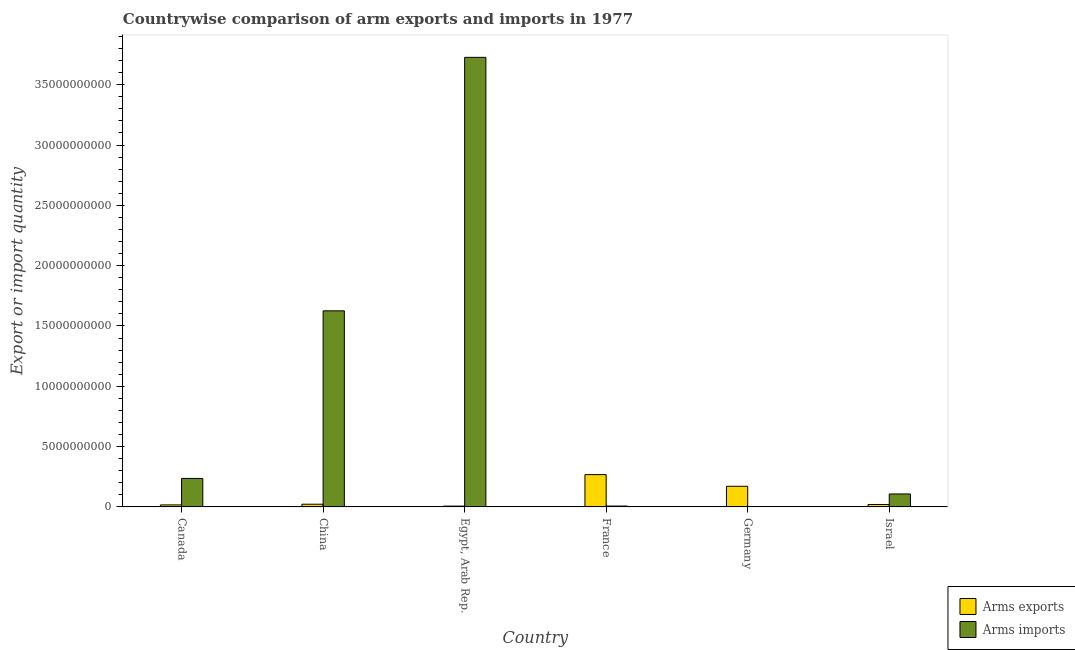How many groups of bars are there?
Make the answer very short. 6. Are the number of bars on each tick of the X-axis equal?
Your response must be concise. Yes. How many bars are there on the 6th tick from the left?
Your answer should be compact. 2. What is the label of the 4th group of bars from the left?
Give a very brief answer. France. What is the arms imports in Egypt, Arab Rep.?
Offer a very short reply. 3.73e+1. Across all countries, what is the maximum arms exports?
Offer a terse response. 2.68e+09. Across all countries, what is the minimum arms exports?
Your answer should be very brief. 6.90e+07. In which country was the arms imports maximum?
Provide a short and direct response. Egypt, Arab Rep. In which country was the arms exports minimum?
Ensure brevity in your answer.  Egypt, Arab Rep. What is the total arms exports in the graph?
Keep it short and to the point. 5.05e+09. What is the difference between the arms exports in Canada and that in China?
Keep it short and to the point. -5.70e+07. What is the difference between the arms exports in China and the arms imports in France?
Keep it short and to the point. 1.50e+08. What is the average arms imports per country?
Your answer should be compact. 9.51e+09. What is the difference between the arms imports and arms exports in Israel?
Keep it short and to the point. 8.73e+08. What is the ratio of the arms exports in China to that in Egypt, Arab Rep.?
Your answer should be compact. 3.25. What is the difference between the highest and the second highest arms exports?
Your response must be concise. 9.66e+08. What is the difference between the highest and the lowest arms imports?
Your response must be concise. 3.73e+1. Is the sum of the arms exports in China and Germany greater than the maximum arms imports across all countries?
Provide a succinct answer. No. What does the 2nd bar from the left in Canada represents?
Your answer should be very brief. Arms imports. What does the 1st bar from the right in France represents?
Offer a very short reply. Arms imports. How many bars are there?
Provide a short and direct response. 12. What is the difference between two consecutive major ticks on the Y-axis?
Ensure brevity in your answer.  5.00e+09. How many legend labels are there?
Your response must be concise. 2. What is the title of the graph?
Your response must be concise. Countrywise comparison of arm exports and imports in 1977. Does "Measles" appear as one of the legend labels in the graph?
Ensure brevity in your answer.  No. What is the label or title of the Y-axis?
Provide a short and direct response. Export or import quantity. What is the Export or import quantity in Arms exports in Canada?
Offer a very short reply. 1.67e+08. What is the Export or import quantity of Arms imports in Canada?
Your response must be concise. 2.36e+09. What is the Export or import quantity in Arms exports in China?
Provide a succinct answer. 2.24e+08. What is the Export or import quantity in Arms imports in China?
Offer a very short reply. 1.63e+1. What is the Export or import quantity in Arms exports in Egypt, Arab Rep.?
Your answer should be very brief. 6.90e+07. What is the Export or import quantity of Arms imports in Egypt, Arab Rep.?
Your answer should be compact. 3.73e+1. What is the Export or import quantity of Arms exports in France?
Provide a short and direct response. 2.68e+09. What is the Export or import quantity in Arms imports in France?
Ensure brevity in your answer.  7.40e+07. What is the Export or import quantity of Arms exports in Germany?
Ensure brevity in your answer.  1.71e+09. What is the Export or import quantity of Arms exports in Israel?
Make the answer very short. 2.02e+08. What is the Export or import quantity of Arms imports in Israel?
Offer a very short reply. 1.08e+09. Across all countries, what is the maximum Export or import quantity in Arms exports?
Provide a succinct answer. 2.68e+09. Across all countries, what is the maximum Export or import quantity in Arms imports?
Your response must be concise. 3.73e+1. Across all countries, what is the minimum Export or import quantity of Arms exports?
Make the answer very short. 6.90e+07. Across all countries, what is the minimum Export or import quantity of Arms imports?
Offer a very short reply. 7.00e+06. What is the total Export or import quantity of Arms exports in the graph?
Ensure brevity in your answer.  5.05e+09. What is the total Export or import quantity in Arms imports in the graph?
Keep it short and to the point. 5.70e+1. What is the difference between the Export or import quantity in Arms exports in Canada and that in China?
Keep it short and to the point. -5.70e+07. What is the difference between the Export or import quantity of Arms imports in Canada and that in China?
Offer a terse response. -1.39e+1. What is the difference between the Export or import quantity in Arms exports in Canada and that in Egypt, Arab Rep.?
Ensure brevity in your answer.  9.80e+07. What is the difference between the Export or import quantity of Arms imports in Canada and that in Egypt, Arab Rep.?
Ensure brevity in your answer.  -3.49e+1. What is the difference between the Export or import quantity of Arms exports in Canada and that in France?
Keep it short and to the point. -2.51e+09. What is the difference between the Export or import quantity in Arms imports in Canada and that in France?
Ensure brevity in your answer.  2.29e+09. What is the difference between the Export or import quantity in Arms exports in Canada and that in Germany?
Offer a terse response. -1.54e+09. What is the difference between the Export or import quantity in Arms imports in Canada and that in Germany?
Ensure brevity in your answer.  2.36e+09. What is the difference between the Export or import quantity in Arms exports in Canada and that in Israel?
Your answer should be very brief. -3.50e+07. What is the difference between the Export or import quantity of Arms imports in Canada and that in Israel?
Offer a very short reply. 1.29e+09. What is the difference between the Export or import quantity of Arms exports in China and that in Egypt, Arab Rep.?
Keep it short and to the point. 1.55e+08. What is the difference between the Export or import quantity in Arms imports in China and that in Egypt, Arab Rep.?
Keep it short and to the point. -2.10e+1. What is the difference between the Export or import quantity in Arms exports in China and that in France?
Offer a terse response. -2.45e+09. What is the difference between the Export or import quantity in Arms imports in China and that in France?
Make the answer very short. 1.62e+1. What is the difference between the Export or import quantity in Arms exports in China and that in Germany?
Keep it short and to the point. -1.49e+09. What is the difference between the Export or import quantity in Arms imports in China and that in Germany?
Your answer should be compact. 1.62e+1. What is the difference between the Export or import quantity in Arms exports in China and that in Israel?
Offer a terse response. 2.20e+07. What is the difference between the Export or import quantity of Arms imports in China and that in Israel?
Your response must be concise. 1.52e+1. What is the difference between the Export or import quantity in Arms exports in Egypt, Arab Rep. and that in France?
Your answer should be very brief. -2.61e+09. What is the difference between the Export or import quantity in Arms imports in Egypt, Arab Rep. and that in France?
Your response must be concise. 3.72e+1. What is the difference between the Export or import quantity of Arms exports in Egypt, Arab Rep. and that in Germany?
Make the answer very short. -1.64e+09. What is the difference between the Export or import quantity in Arms imports in Egypt, Arab Rep. and that in Germany?
Your answer should be very brief. 3.73e+1. What is the difference between the Export or import quantity of Arms exports in Egypt, Arab Rep. and that in Israel?
Keep it short and to the point. -1.33e+08. What is the difference between the Export or import quantity of Arms imports in Egypt, Arab Rep. and that in Israel?
Offer a very short reply. 3.62e+1. What is the difference between the Export or import quantity in Arms exports in France and that in Germany?
Offer a terse response. 9.66e+08. What is the difference between the Export or import quantity in Arms imports in France and that in Germany?
Your answer should be very brief. 6.70e+07. What is the difference between the Export or import quantity of Arms exports in France and that in Israel?
Keep it short and to the point. 2.48e+09. What is the difference between the Export or import quantity in Arms imports in France and that in Israel?
Ensure brevity in your answer.  -1.00e+09. What is the difference between the Export or import quantity in Arms exports in Germany and that in Israel?
Make the answer very short. 1.51e+09. What is the difference between the Export or import quantity of Arms imports in Germany and that in Israel?
Your answer should be compact. -1.07e+09. What is the difference between the Export or import quantity of Arms exports in Canada and the Export or import quantity of Arms imports in China?
Keep it short and to the point. -1.61e+1. What is the difference between the Export or import quantity in Arms exports in Canada and the Export or import quantity in Arms imports in Egypt, Arab Rep.?
Offer a terse response. -3.71e+1. What is the difference between the Export or import quantity of Arms exports in Canada and the Export or import quantity of Arms imports in France?
Your response must be concise. 9.30e+07. What is the difference between the Export or import quantity in Arms exports in Canada and the Export or import quantity in Arms imports in Germany?
Offer a terse response. 1.60e+08. What is the difference between the Export or import quantity in Arms exports in Canada and the Export or import quantity in Arms imports in Israel?
Your answer should be compact. -9.08e+08. What is the difference between the Export or import quantity in Arms exports in China and the Export or import quantity in Arms imports in Egypt, Arab Rep.?
Ensure brevity in your answer.  -3.70e+1. What is the difference between the Export or import quantity of Arms exports in China and the Export or import quantity of Arms imports in France?
Offer a very short reply. 1.50e+08. What is the difference between the Export or import quantity of Arms exports in China and the Export or import quantity of Arms imports in Germany?
Keep it short and to the point. 2.17e+08. What is the difference between the Export or import quantity in Arms exports in China and the Export or import quantity in Arms imports in Israel?
Ensure brevity in your answer.  -8.51e+08. What is the difference between the Export or import quantity of Arms exports in Egypt, Arab Rep. and the Export or import quantity of Arms imports in France?
Your response must be concise. -5.00e+06. What is the difference between the Export or import quantity of Arms exports in Egypt, Arab Rep. and the Export or import quantity of Arms imports in Germany?
Make the answer very short. 6.20e+07. What is the difference between the Export or import quantity in Arms exports in Egypt, Arab Rep. and the Export or import quantity in Arms imports in Israel?
Keep it short and to the point. -1.01e+09. What is the difference between the Export or import quantity of Arms exports in France and the Export or import quantity of Arms imports in Germany?
Keep it short and to the point. 2.67e+09. What is the difference between the Export or import quantity of Arms exports in France and the Export or import quantity of Arms imports in Israel?
Give a very brief answer. 1.60e+09. What is the difference between the Export or import quantity in Arms exports in Germany and the Export or import quantity in Arms imports in Israel?
Your answer should be very brief. 6.37e+08. What is the average Export or import quantity in Arms exports per country?
Provide a succinct answer. 8.42e+08. What is the average Export or import quantity of Arms imports per country?
Your answer should be compact. 9.51e+09. What is the difference between the Export or import quantity in Arms exports and Export or import quantity in Arms imports in Canada?
Offer a terse response. -2.20e+09. What is the difference between the Export or import quantity of Arms exports and Export or import quantity of Arms imports in China?
Your response must be concise. -1.60e+1. What is the difference between the Export or import quantity of Arms exports and Export or import quantity of Arms imports in Egypt, Arab Rep.?
Make the answer very short. -3.72e+1. What is the difference between the Export or import quantity of Arms exports and Export or import quantity of Arms imports in France?
Offer a very short reply. 2.60e+09. What is the difference between the Export or import quantity of Arms exports and Export or import quantity of Arms imports in Germany?
Offer a terse response. 1.70e+09. What is the difference between the Export or import quantity in Arms exports and Export or import quantity in Arms imports in Israel?
Make the answer very short. -8.73e+08. What is the ratio of the Export or import quantity in Arms exports in Canada to that in China?
Offer a terse response. 0.75. What is the ratio of the Export or import quantity of Arms imports in Canada to that in China?
Make the answer very short. 0.15. What is the ratio of the Export or import quantity in Arms exports in Canada to that in Egypt, Arab Rep.?
Your answer should be compact. 2.42. What is the ratio of the Export or import quantity in Arms imports in Canada to that in Egypt, Arab Rep.?
Offer a very short reply. 0.06. What is the ratio of the Export or import quantity in Arms exports in Canada to that in France?
Give a very brief answer. 0.06. What is the ratio of the Export or import quantity of Arms imports in Canada to that in France?
Offer a terse response. 31.93. What is the ratio of the Export or import quantity of Arms exports in Canada to that in Germany?
Make the answer very short. 0.1. What is the ratio of the Export or import quantity of Arms imports in Canada to that in Germany?
Your answer should be compact. 337.57. What is the ratio of the Export or import quantity in Arms exports in Canada to that in Israel?
Provide a short and direct response. 0.83. What is the ratio of the Export or import quantity of Arms imports in Canada to that in Israel?
Give a very brief answer. 2.2. What is the ratio of the Export or import quantity in Arms exports in China to that in Egypt, Arab Rep.?
Provide a short and direct response. 3.25. What is the ratio of the Export or import quantity in Arms imports in China to that in Egypt, Arab Rep.?
Provide a succinct answer. 0.44. What is the ratio of the Export or import quantity in Arms exports in China to that in France?
Provide a succinct answer. 0.08. What is the ratio of the Export or import quantity of Arms imports in China to that in France?
Offer a very short reply. 219.66. What is the ratio of the Export or import quantity in Arms exports in China to that in Germany?
Your response must be concise. 0.13. What is the ratio of the Export or import quantity in Arms imports in China to that in Germany?
Your answer should be compact. 2322.14. What is the ratio of the Export or import quantity in Arms exports in China to that in Israel?
Provide a succinct answer. 1.11. What is the ratio of the Export or import quantity of Arms imports in China to that in Israel?
Provide a short and direct response. 15.12. What is the ratio of the Export or import quantity in Arms exports in Egypt, Arab Rep. to that in France?
Offer a terse response. 0.03. What is the ratio of the Export or import quantity of Arms imports in Egypt, Arab Rep. to that in France?
Offer a terse response. 503.59. What is the ratio of the Export or import quantity of Arms exports in Egypt, Arab Rep. to that in Germany?
Give a very brief answer. 0.04. What is the ratio of the Export or import quantity of Arms imports in Egypt, Arab Rep. to that in Germany?
Provide a succinct answer. 5323.71. What is the ratio of the Export or import quantity in Arms exports in Egypt, Arab Rep. to that in Israel?
Your response must be concise. 0.34. What is the ratio of the Export or import quantity in Arms imports in Egypt, Arab Rep. to that in Israel?
Your answer should be compact. 34.67. What is the ratio of the Export or import quantity in Arms exports in France to that in Germany?
Make the answer very short. 1.56. What is the ratio of the Export or import quantity in Arms imports in France to that in Germany?
Make the answer very short. 10.57. What is the ratio of the Export or import quantity in Arms exports in France to that in Israel?
Offer a very short reply. 13.26. What is the ratio of the Export or import quantity of Arms imports in France to that in Israel?
Keep it short and to the point. 0.07. What is the ratio of the Export or import quantity in Arms exports in Germany to that in Israel?
Make the answer very short. 8.48. What is the ratio of the Export or import quantity of Arms imports in Germany to that in Israel?
Your response must be concise. 0.01. What is the difference between the highest and the second highest Export or import quantity in Arms exports?
Offer a very short reply. 9.66e+08. What is the difference between the highest and the second highest Export or import quantity in Arms imports?
Keep it short and to the point. 2.10e+1. What is the difference between the highest and the lowest Export or import quantity of Arms exports?
Your response must be concise. 2.61e+09. What is the difference between the highest and the lowest Export or import quantity in Arms imports?
Provide a succinct answer. 3.73e+1. 